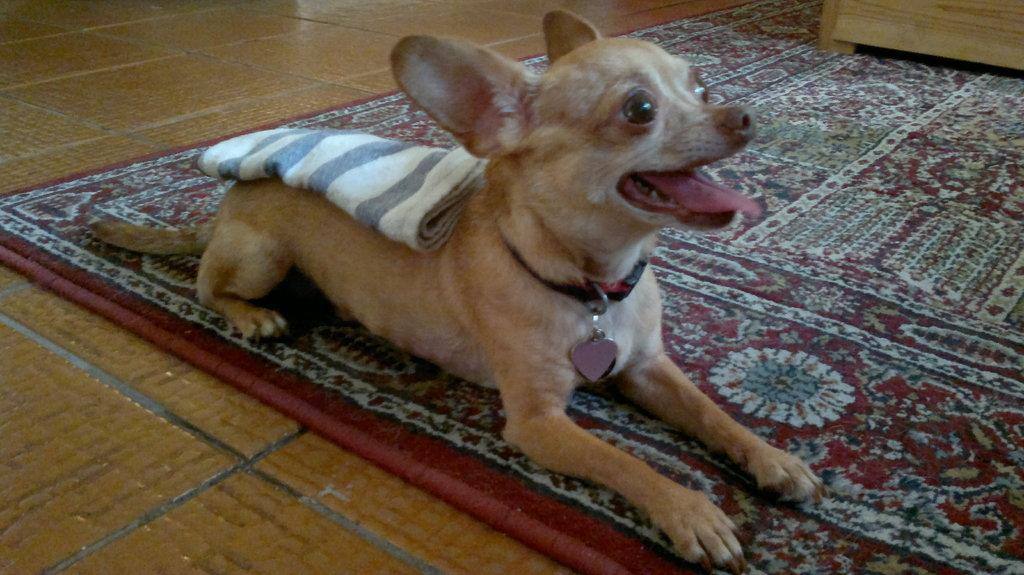What type of animal is in the image? There is a dog in the image. What is the dog wearing? The dog is wearing a cloth. Where is the dog sitting? The dog is sitting on a carpet. What can be seen in the top right corner of the image? There is a wooden object in the top right corner of the image. What type of music is the dog playing in the image? There is no music or instrument present in the image, so the dog cannot be playing any music. 